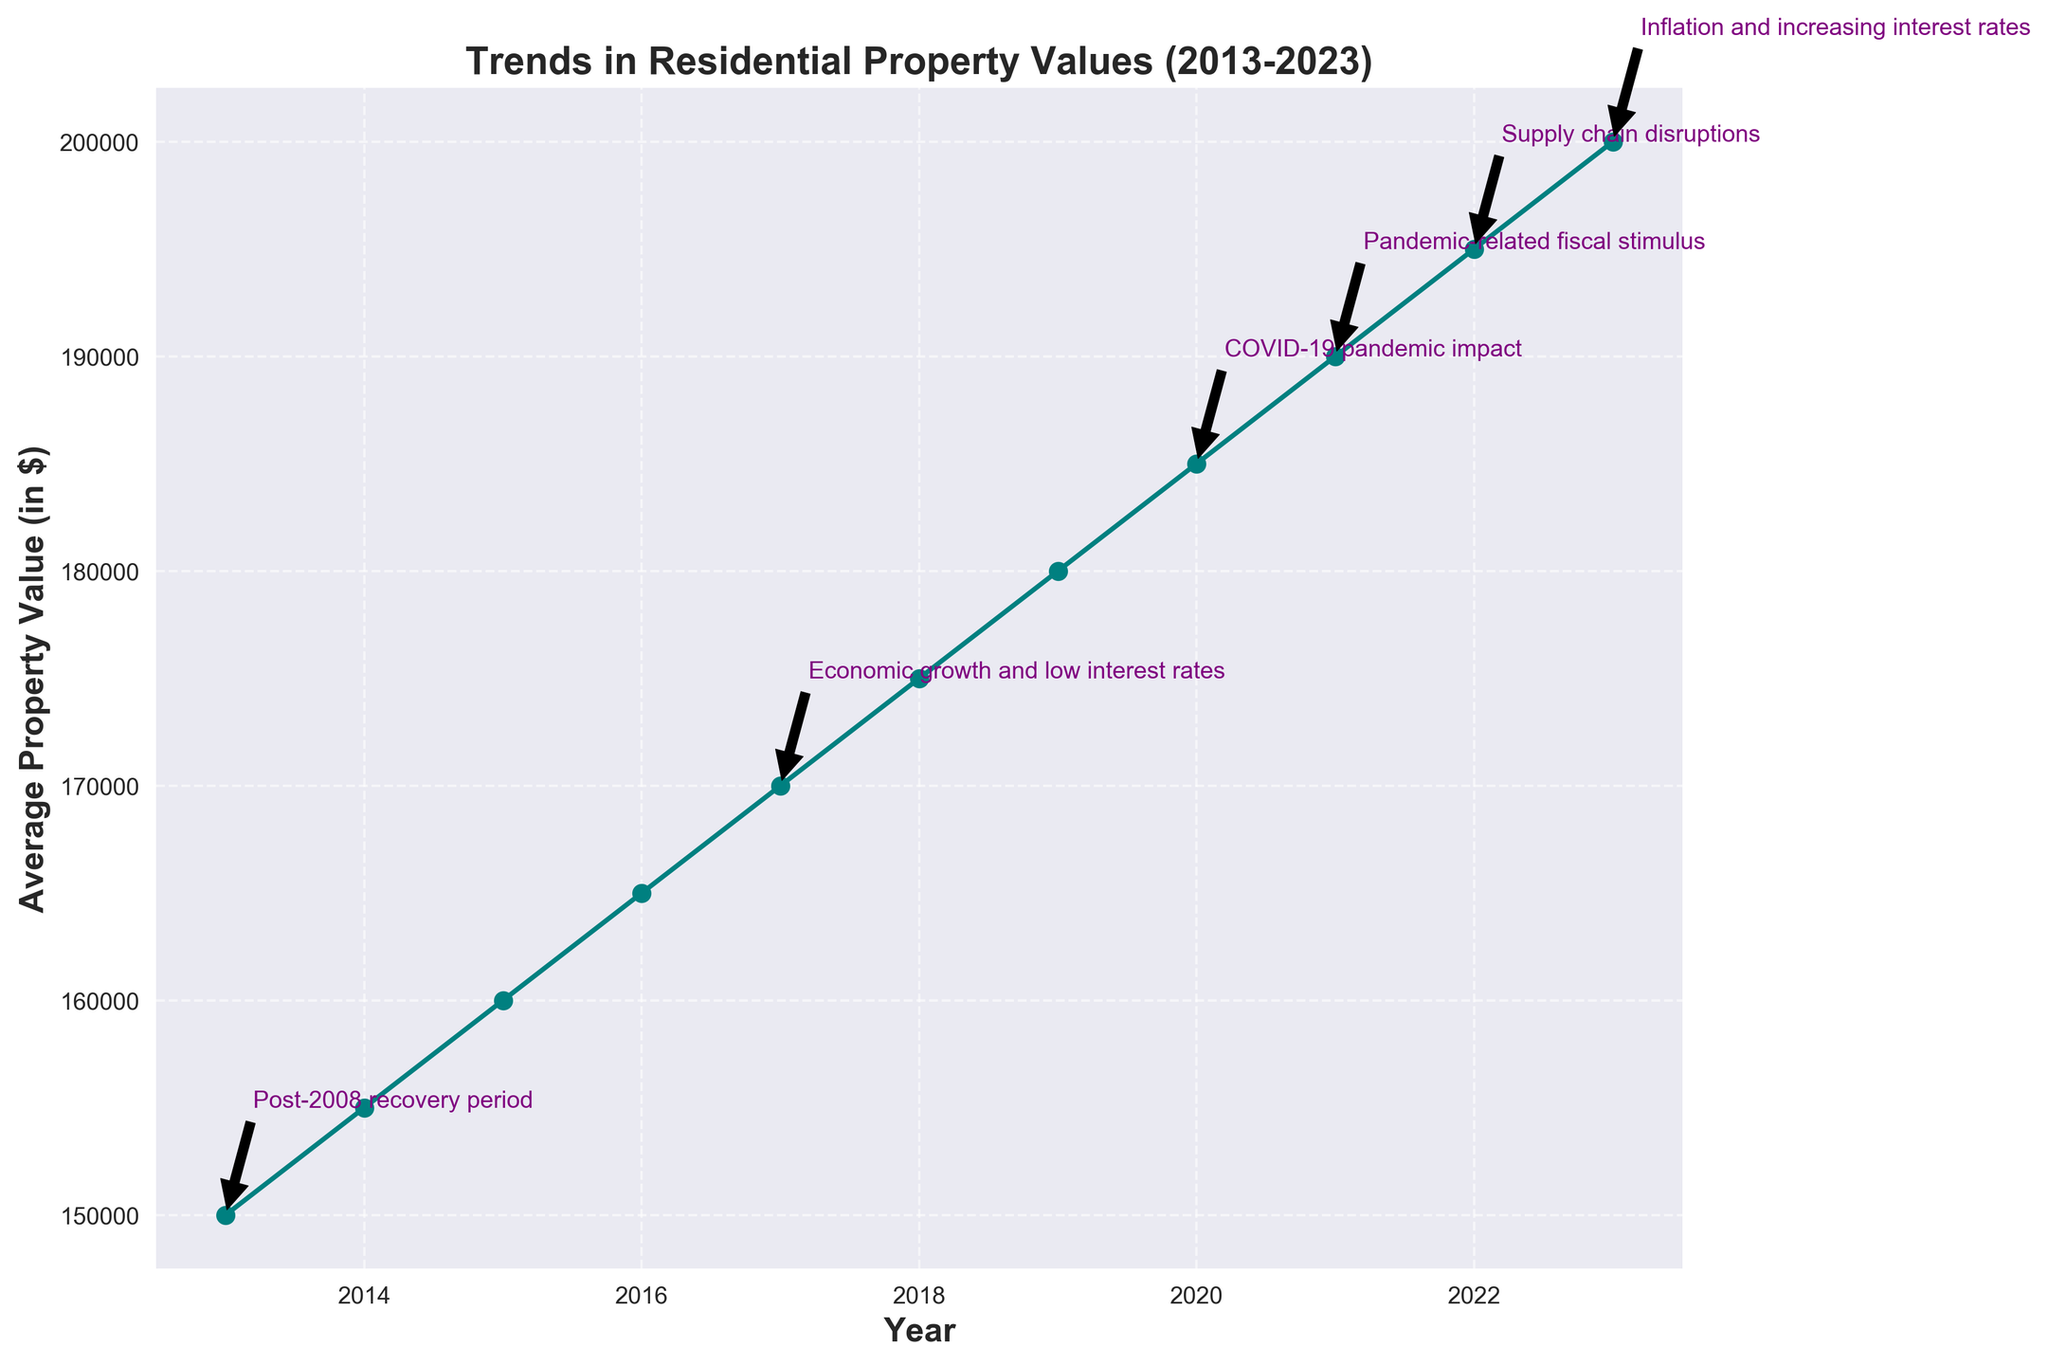What's the highest average property value over the decade? To find the highest average property value, look at the y-axis values of the plotted line. The value for 2023 is the highest.
Answer: 200000 How did the average property value change from 2020 to 2021, considering annotations? Compare the y-axis values for 2020 and 2021. There's a rise from 185000 in 2020 to 190000 in 2021, potentially due to pandemic-related fiscal stimulus.
Answer: 5000 increase Which economic event is annotated for the year 2023? Identify the annotation for 2023. The text near the year indicates "Inflation and increasing interest rates."
Answer: Inflation and increasing interest rates What was the average property value during the "COVID-19 pandemic impact" period? Find the year associated with the annotation "COVID-19 pandemic impact," which is 2020, indicating the average property value was 185000.
Answer: 185000 Between which years did the average property value see the largest increase? To identify the largest increase, calculate the difference in property values year-by-year. The largest difference is between 2018 (175000) and 2019 (180000), a 5000 increase.
Answer: Between 2018 and 2019 What's the sum of the average property values for 2017 and 2023? Add the average property values for 2017 (170000) and 2023 (200000).
Answer: 370000 Compare the average property value in 2019 to 2020. What is the difference? Subtract the 2019 value (180000) from the 2020 value (185000).
Answer: 5000 Does the property value trend show a steady increase over the decade? Examine the overall trajectory of the line from 2013 to 2023. The line moves upward consistently without any declines, showing a steady increase.
Answer: Yes How does the average property value in 2013 compare to 2023? Compare the values for 2013 (150000) and 2023 (200000) by calculating the difference or percentage increase.
Answer: 50000 increase 